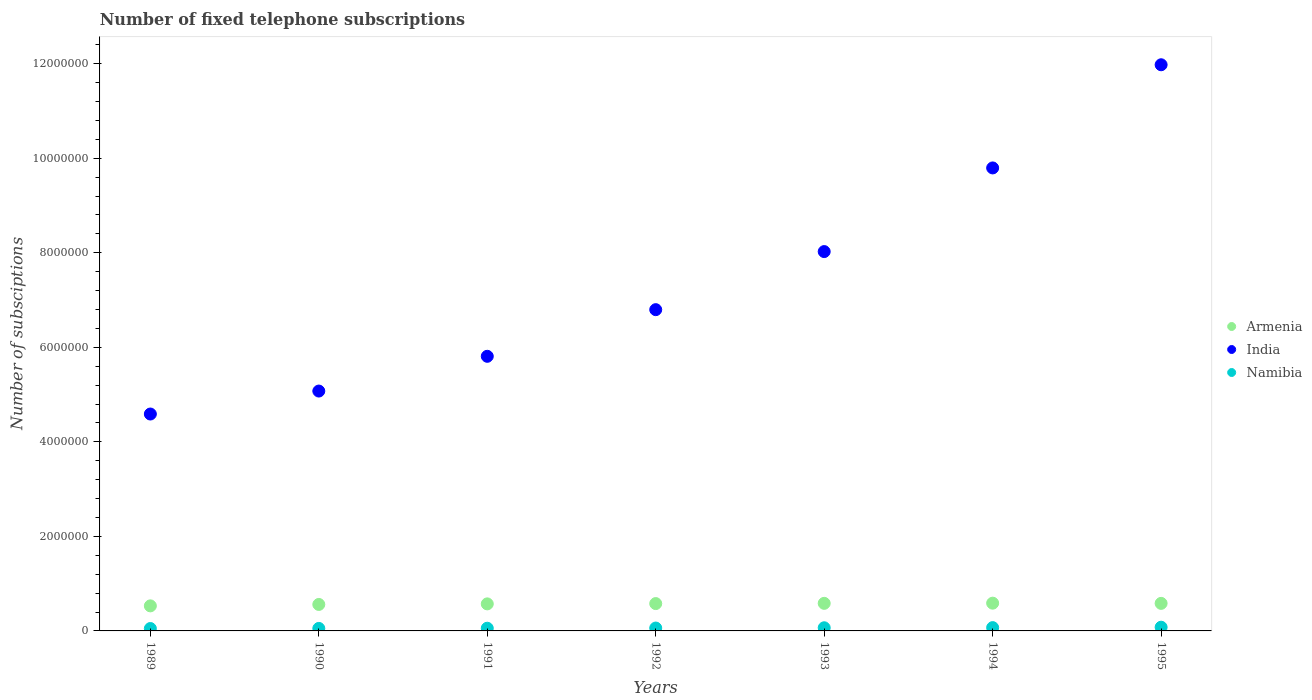How many different coloured dotlines are there?
Your answer should be very brief. 3. What is the number of fixed telephone subscriptions in Armenia in 1989?
Provide a succinct answer. 5.30e+05. Across all years, what is the maximum number of fixed telephone subscriptions in Namibia?
Offer a terse response. 7.85e+04. Across all years, what is the minimum number of fixed telephone subscriptions in Namibia?
Your answer should be very brief. 5.07e+04. In which year was the number of fixed telephone subscriptions in Armenia maximum?
Ensure brevity in your answer.  1994. In which year was the number of fixed telephone subscriptions in Armenia minimum?
Your answer should be compact. 1989. What is the total number of fixed telephone subscriptions in India in the graph?
Provide a succinct answer. 5.21e+07. What is the difference between the number of fixed telephone subscriptions in India in 1991 and that in 1995?
Your answer should be compact. -6.17e+06. What is the difference between the number of fixed telephone subscriptions in Namibia in 1993 and the number of fixed telephone subscriptions in India in 1992?
Make the answer very short. -6.73e+06. What is the average number of fixed telephone subscriptions in Namibia per year?
Your answer should be compact. 6.24e+04. In the year 1990, what is the difference between the number of fixed telephone subscriptions in Armenia and number of fixed telephone subscriptions in Namibia?
Provide a succinct answer. 5.07e+05. In how many years, is the number of fixed telephone subscriptions in India greater than 10400000?
Keep it short and to the point. 1. What is the ratio of the number of fixed telephone subscriptions in Namibia in 1989 to that in 1995?
Make the answer very short. 0.65. Is the number of fixed telephone subscriptions in Armenia in 1990 less than that in 1991?
Keep it short and to the point. Yes. Is the difference between the number of fixed telephone subscriptions in Armenia in 1992 and 1994 greater than the difference between the number of fixed telephone subscriptions in Namibia in 1992 and 1994?
Give a very brief answer. Yes. What is the difference between the highest and the second highest number of fixed telephone subscriptions in India?
Your response must be concise. 2.18e+06. What is the difference between the highest and the lowest number of fixed telephone subscriptions in Namibia?
Your answer should be very brief. 2.78e+04. In how many years, is the number of fixed telephone subscriptions in India greater than the average number of fixed telephone subscriptions in India taken over all years?
Provide a succinct answer. 3. Is the sum of the number of fixed telephone subscriptions in India in 1989 and 1994 greater than the maximum number of fixed telephone subscriptions in Namibia across all years?
Make the answer very short. Yes. Is it the case that in every year, the sum of the number of fixed telephone subscriptions in Armenia and number of fixed telephone subscriptions in Namibia  is greater than the number of fixed telephone subscriptions in India?
Offer a very short reply. No. Does the number of fixed telephone subscriptions in Armenia monotonically increase over the years?
Your response must be concise. No. Is the number of fixed telephone subscriptions in India strictly greater than the number of fixed telephone subscriptions in Namibia over the years?
Give a very brief answer. Yes. Is the number of fixed telephone subscriptions in Armenia strictly less than the number of fixed telephone subscriptions in Namibia over the years?
Provide a succinct answer. No. How many dotlines are there?
Keep it short and to the point. 3. What is the difference between two consecutive major ticks on the Y-axis?
Make the answer very short. 2.00e+06. Are the values on the major ticks of Y-axis written in scientific E-notation?
Provide a succinct answer. No. How many legend labels are there?
Your response must be concise. 3. How are the legend labels stacked?
Give a very brief answer. Vertical. What is the title of the graph?
Offer a very short reply. Number of fixed telephone subscriptions. What is the label or title of the Y-axis?
Offer a very short reply. Number of subsciptions. What is the Number of subsciptions of Armenia in 1989?
Your answer should be compact. 5.30e+05. What is the Number of subsciptions in India in 1989?
Offer a terse response. 4.59e+06. What is the Number of subsciptions in Namibia in 1989?
Provide a short and direct response. 5.07e+04. What is the Number of subsciptions of Armenia in 1990?
Offer a very short reply. 5.60e+05. What is the Number of subsciptions of India in 1990?
Provide a short and direct response. 5.07e+06. What is the Number of subsciptions of Namibia in 1990?
Offer a terse response. 5.30e+04. What is the Number of subsciptions in Armenia in 1991?
Offer a very short reply. 5.72e+05. What is the Number of subsciptions in India in 1991?
Provide a short and direct response. 5.81e+06. What is the Number of subsciptions of Namibia in 1991?
Keep it short and to the point. 5.69e+04. What is the Number of subsciptions in Armenia in 1992?
Keep it short and to the point. 5.78e+05. What is the Number of subsciptions in India in 1992?
Keep it short and to the point. 6.80e+06. What is the Number of subsciptions of Namibia in 1992?
Offer a very short reply. 6.10e+04. What is the Number of subsciptions of Armenia in 1993?
Your answer should be very brief. 5.83e+05. What is the Number of subsciptions in India in 1993?
Make the answer very short. 8.03e+06. What is the Number of subsciptions of Namibia in 1993?
Your response must be concise. 6.67e+04. What is the Number of subsciptions of Armenia in 1994?
Provide a succinct answer. 5.87e+05. What is the Number of subsciptions of India in 1994?
Your answer should be compact. 9.80e+06. What is the Number of subsciptions in Namibia in 1994?
Keep it short and to the point. 6.98e+04. What is the Number of subsciptions of Armenia in 1995?
Keep it short and to the point. 5.83e+05. What is the Number of subsciptions in India in 1995?
Give a very brief answer. 1.20e+07. What is the Number of subsciptions in Namibia in 1995?
Offer a terse response. 7.85e+04. Across all years, what is the maximum Number of subsciptions of Armenia?
Provide a short and direct response. 5.87e+05. Across all years, what is the maximum Number of subsciptions of India?
Ensure brevity in your answer.  1.20e+07. Across all years, what is the maximum Number of subsciptions of Namibia?
Ensure brevity in your answer.  7.85e+04. Across all years, what is the minimum Number of subsciptions in Armenia?
Provide a short and direct response. 5.30e+05. Across all years, what is the minimum Number of subsciptions of India?
Provide a succinct answer. 4.59e+06. Across all years, what is the minimum Number of subsciptions in Namibia?
Ensure brevity in your answer.  5.07e+04. What is the total Number of subsciptions in Armenia in the graph?
Offer a very short reply. 3.99e+06. What is the total Number of subsciptions of India in the graph?
Your answer should be very brief. 5.21e+07. What is the total Number of subsciptions of Namibia in the graph?
Provide a succinct answer. 4.37e+05. What is the difference between the Number of subsciptions of Armenia in 1989 and that in 1990?
Your response must be concise. -3.00e+04. What is the difference between the Number of subsciptions in India in 1989 and that in 1990?
Provide a succinct answer. -4.86e+05. What is the difference between the Number of subsciptions in Namibia in 1989 and that in 1990?
Your answer should be compact. -2332. What is the difference between the Number of subsciptions of Armenia in 1989 and that in 1991?
Give a very brief answer. -4.21e+04. What is the difference between the Number of subsciptions in India in 1989 and that in 1991?
Your answer should be very brief. -1.22e+06. What is the difference between the Number of subsciptions of Namibia in 1989 and that in 1991?
Your answer should be compact. -6271. What is the difference between the Number of subsciptions of Armenia in 1989 and that in 1992?
Provide a succinct answer. -4.84e+04. What is the difference between the Number of subsciptions in India in 1989 and that in 1992?
Your answer should be very brief. -2.21e+06. What is the difference between the Number of subsciptions of Namibia in 1989 and that in 1992?
Give a very brief answer. -1.03e+04. What is the difference between the Number of subsciptions in Armenia in 1989 and that in 1993?
Offer a terse response. -5.35e+04. What is the difference between the Number of subsciptions of India in 1989 and that in 1993?
Provide a succinct answer. -3.44e+06. What is the difference between the Number of subsciptions in Namibia in 1989 and that in 1993?
Your answer should be very brief. -1.61e+04. What is the difference between the Number of subsciptions in Armenia in 1989 and that in 1994?
Your answer should be compact. -5.71e+04. What is the difference between the Number of subsciptions in India in 1989 and that in 1994?
Your answer should be very brief. -5.21e+06. What is the difference between the Number of subsciptions in Namibia in 1989 and that in 1994?
Provide a short and direct response. -1.91e+04. What is the difference between the Number of subsciptions in Armenia in 1989 and that in 1995?
Offer a very short reply. -5.28e+04. What is the difference between the Number of subsciptions of India in 1989 and that in 1995?
Your answer should be very brief. -7.39e+06. What is the difference between the Number of subsciptions in Namibia in 1989 and that in 1995?
Provide a succinct answer. -2.78e+04. What is the difference between the Number of subsciptions in Armenia in 1990 and that in 1991?
Provide a short and direct response. -1.21e+04. What is the difference between the Number of subsciptions in India in 1990 and that in 1991?
Provide a succinct answer. -7.35e+05. What is the difference between the Number of subsciptions of Namibia in 1990 and that in 1991?
Offer a terse response. -3939. What is the difference between the Number of subsciptions in Armenia in 1990 and that in 1992?
Your response must be concise. -1.84e+04. What is the difference between the Number of subsciptions in India in 1990 and that in 1992?
Offer a terse response. -1.72e+06. What is the difference between the Number of subsciptions of Namibia in 1990 and that in 1992?
Provide a short and direct response. -7974. What is the difference between the Number of subsciptions of Armenia in 1990 and that in 1993?
Make the answer very short. -2.35e+04. What is the difference between the Number of subsciptions of India in 1990 and that in 1993?
Provide a short and direct response. -2.95e+06. What is the difference between the Number of subsciptions of Namibia in 1990 and that in 1993?
Offer a very short reply. -1.37e+04. What is the difference between the Number of subsciptions of Armenia in 1990 and that in 1994?
Ensure brevity in your answer.  -2.71e+04. What is the difference between the Number of subsciptions in India in 1990 and that in 1994?
Provide a short and direct response. -4.72e+06. What is the difference between the Number of subsciptions in Namibia in 1990 and that in 1994?
Ensure brevity in your answer.  -1.68e+04. What is the difference between the Number of subsciptions of Armenia in 1990 and that in 1995?
Your answer should be very brief. -2.28e+04. What is the difference between the Number of subsciptions in India in 1990 and that in 1995?
Ensure brevity in your answer.  -6.90e+06. What is the difference between the Number of subsciptions of Namibia in 1990 and that in 1995?
Your answer should be very brief. -2.55e+04. What is the difference between the Number of subsciptions of Armenia in 1991 and that in 1992?
Make the answer very short. -6300. What is the difference between the Number of subsciptions in India in 1991 and that in 1992?
Keep it short and to the point. -9.87e+05. What is the difference between the Number of subsciptions in Namibia in 1991 and that in 1992?
Offer a very short reply. -4035. What is the difference between the Number of subsciptions of Armenia in 1991 and that in 1993?
Make the answer very short. -1.14e+04. What is the difference between the Number of subsciptions of India in 1991 and that in 1993?
Your answer should be compact. -2.22e+06. What is the difference between the Number of subsciptions in Namibia in 1991 and that in 1993?
Provide a succinct answer. -9810. What is the difference between the Number of subsciptions in Armenia in 1991 and that in 1994?
Offer a terse response. -1.50e+04. What is the difference between the Number of subsciptions in India in 1991 and that in 1994?
Provide a succinct answer. -3.99e+06. What is the difference between the Number of subsciptions of Namibia in 1991 and that in 1994?
Keep it short and to the point. -1.28e+04. What is the difference between the Number of subsciptions of Armenia in 1991 and that in 1995?
Your answer should be very brief. -1.07e+04. What is the difference between the Number of subsciptions of India in 1991 and that in 1995?
Offer a terse response. -6.17e+06. What is the difference between the Number of subsciptions in Namibia in 1991 and that in 1995?
Your answer should be very brief. -2.16e+04. What is the difference between the Number of subsciptions of Armenia in 1992 and that in 1993?
Your answer should be very brief. -5060. What is the difference between the Number of subsciptions of India in 1992 and that in 1993?
Provide a short and direct response. -1.23e+06. What is the difference between the Number of subsciptions of Namibia in 1992 and that in 1993?
Offer a very short reply. -5775. What is the difference between the Number of subsciptions in Armenia in 1992 and that in 1994?
Ensure brevity in your answer.  -8713. What is the difference between the Number of subsciptions in India in 1992 and that in 1994?
Your answer should be very brief. -3.00e+06. What is the difference between the Number of subsciptions in Namibia in 1992 and that in 1994?
Offer a very short reply. -8810. What is the difference between the Number of subsciptions of Armenia in 1992 and that in 1995?
Make the answer very short. -4400. What is the difference between the Number of subsciptions of India in 1992 and that in 1995?
Provide a succinct answer. -5.18e+06. What is the difference between the Number of subsciptions in Namibia in 1992 and that in 1995?
Your answer should be very brief. -1.75e+04. What is the difference between the Number of subsciptions of Armenia in 1993 and that in 1994?
Your answer should be compact. -3653. What is the difference between the Number of subsciptions in India in 1993 and that in 1994?
Ensure brevity in your answer.  -1.77e+06. What is the difference between the Number of subsciptions of Namibia in 1993 and that in 1994?
Keep it short and to the point. -3035. What is the difference between the Number of subsciptions of Armenia in 1993 and that in 1995?
Your answer should be compact. 660. What is the difference between the Number of subsciptions in India in 1993 and that in 1995?
Offer a terse response. -3.95e+06. What is the difference between the Number of subsciptions in Namibia in 1993 and that in 1995?
Give a very brief answer. -1.18e+04. What is the difference between the Number of subsciptions in Armenia in 1994 and that in 1995?
Ensure brevity in your answer.  4313. What is the difference between the Number of subsciptions in India in 1994 and that in 1995?
Provide a succinct answer. -2.18e+06. What is the difference between the Number of subsciptions of Namibia in 1994 and that in 1995?
Give a very brief answer. -8715. What is the difference between the Number of subsciptions in Armenia in 1989 and the Number of subsciptions in India in 1990?
Offer a terse response. -4.54e+06. What is the difference between the Number of subsciptions of Armenia in 1989 and the Number of subsciptions of Namibia in 1990?
Offer a terse response. 4.77e+05. What is the difference between the Number of subsciptions of India in 1989 and the Number of subsciptions of Namibia in 1990?
Keep it short and to the point. 4.54e+06. What is the difference between the Number of subsciptions in Armenia in 1989 and the Number of subsciptions in India in 1991?
Keep it short and to the point. -5.28e+06. What is the difference between the Number of subsciptions in Armenia in 1989 and the Number of subsciptions in Namibia in 1991?
Your answer should be compact. 4.73e+05. What is the difference between the Number of subsciptions in India in 1989 and the Number of subsciptions in Namibia in 1991?
Provide a short and direct response. 4.53e+06. What is the difference between the Number of subsciptions of Armenia in 1989 and the Number of subsciptions of India in 1992?
Provide a short and direct response. -6.27e+06. What is the difference between the Number of subsciptions of Armenia in 1989 and the Number of subsciptions of Namibia in 1992?
Offer a very short reply. 4.69e+05. What is the difference between the Number of subsciptions of India in 1989 and the Number of subsciptions of Namibia in 1992?
Make the answer very short. 4.53e+06. What is the difference between the Number of subsciptions of Armenia in 1989 and the Number of subsciptions of India in 1993?
Make the answer very short. -7.50e+06. What is the difference between the Number of subsciptions in Armenia in 1989 and the Number of subsciptions in Namibia in 1993?
Keep it short and to the point. 4.63e+05. What is the difference between the Number of subsciptions in India in 1989 and the Number of subsciptions in Namibia in 1993?
Provide a succinct answer. 4.52e+06. What is the difference between the Number of subsciptions of Armenia in 1989 and the Number of subsciptions of India in 1994?
Your response must be concise. -9.27e+06. What is the difference between the Number of subsciptions in Armenia in 1989 and the Number of subsciptions in Namibia in 1994?
Offer a terse response. 4.60e+05. What is the difference between the Number of subsciptions in India in 1989 and the Number of subsciptions in Namibia in 1994?
Provide a short and direct response. 4.52e+06. What is the difference between the Number of subsciptions of Armenia in 1989 and the Number of subsciptions of India in 1995?
Provide a short and direct response. -1.14e+07. What is the difference between the Number of subsciptions of Armenia in 1989 and the Number of subsciptions of Namibia in 1995?
Make the answer very short. 4.52e+05. What is the difference between the Number of subsciptions of India in 1989 and the Number of subsciptions of Namibia in 1995?
Provide a short and direct response. 4.51e+06. What is the difference between the Number of subsciptions of Armenia in 1990 and the Number of subsciptions of India in 1991?
Make the answer very short. -5.25e+06. What is the difference between the Number of subsciptions of Armenia in 1990 and the Number of subsciptions of Namibia in 1991?
Offer a terse response. 5.03e+05. What is the difference between the Number of subsciptions of India in 1990 and the Number of subsciptions of Namibia in 1991?
Offer a very short reply. 5.02e+06. What is the difference between the Number of subsciptions of Armenia in 1990 and the Number of subsciptions of India in 1992?
Make the answer very short. -6.24e+06. What is the difference between the Number of subsciptions of Armenia in 1990 and the Number of subsciptions of Namibia in 1992?
Offer a very short reply. 4.99e+05. What is the difference between the Number of subsciptions of India in 1990 and the Number of subsciptions of Namibia in 1992?
Your answer should be very brief. 5.01e+06. What is the difference between the Number of subsciptions of Armenia in 1990 and the Number of subsciptions of India in 1993?
Provide a succinct answer. -7.47e+06. What is the difference between the Number of subsciptions in Armenia in 1990 and the Number of subsciptions in Namibia in 1993?
Make the answer very short. 4.93e+05. What is the difference between the Number of subsciptions in India in 1990 and the Number of subsciptions in Namibia in 1993?
Keep it short and to the point. 5.01e+06. What is the difference between the Number of subsciptions in Armenia in 1990 and the Number of subsciptions in India in 1994?
Your response must be concise. -9.24e+06. What is the difference between the Number of subsciptions of Armenia in 1990 and the Number of subsciptions of Namibia in 1994?
Offer a terse response. 4.90e+05. What is the difference between the Number of subsciptions of India in 1990 and the Number of subsciptions of Namibia in 1994?
Your answer should be compact. 5.00e+06. What is the difference between the Number of subsciptions in Armenia in 1990 and the Number of subsciptions in India in 1995?
Provide a short and direct response. -1.14e+07. What is the difference between the Number of subsciptions in Armenia in 1990 and the Number of subsciptions in Namibia in 1995?
Ensure brevity in your answer.  4.82e+05. What is the difference between the Number of subsciptions of India in 1990 and the Number of subsciptions of Namibia in 1995?
Your answer should be very brief. 5.00e+06. What is the difference between the Number of subsciptions of Armenia in 1991 and the Number of subsciptions of India in 1992?
Keep it short and to the point. -6.22e+06. What is the difference between the Number of subsciptions of Armenia in 1991 and the Number of subsciptions of Namibia in 1992?
Ensure brevity in your answer.  5.11e+05. What is the difference between the Number of subsciptions in India in 1991 and the Number of subsciptions in Namibia in 1992?
Keep it short and to the point. 5.75e+06. What is the difference between the Number of subsciptions of Armenia in 1991 and the Number of subsciptions of India in 1993?
Offer a terse response. -7.45e+06. What is the difference between the Number of subsciptions of Armenia in 1991 and the Number of subsciptions of Namibia in 1993?
Ensure brevity in your answer.  5.05e+05. What is the difference between the Number of subsciptions of India in 1991 and the Number of subsciptions of Namibia in 1993?
Ensure brevity in your answer.  5.74e+06. What is the difference between the Number of subsciptions in Armenia in 1991 and the Number of subsciptions in India in 1994?
Provide a succinct answer. -9.22e+06. What is the difference between the Number of subsciptions of Armenia in 1991 and the Number of subsciptions of Namibia in 1994?
Offer a terse response. 5.02e+05. What is the difference between the Number of subsciptions of India in 1991 and the Number of subsciptions of Namibia in 1994?
Provide a succinct answer. 5.74e+06. What is the difference between the Number of subsciptions in Armenia in 1991 and the Number of subsciptions in India in 1995?
Ensure brevity in your answer.  -1.14e+07. What is the difference between the Number of subsciptions in Armenia in 1991 and the Number of subsciptions in Namibia in 1995?
Ensure brevity in your answer.  4.94e+05. What is the difference between the Number of subsciptions in India in 1991 and the Number of subsciptions in Namibia in 1995?
Make the answer very short. 5.73e+06. What is the difference between the Number of subsciptions of Armenia in 1992 and the Number of subsciptions of India in 1993?
Provide a short and direct response. -7.45e+06. What is the difference between the Number of subsciptions in Armenia in 1992 and the Number of subsciptions in Namibia in 1993?
Provide a short and direct response. 5.12e+05. What is the difference between the Number of subsciptions in India in 1992 and the Number of subsciptions in Namibia in 1993?
Your answer should be very brief. 6.73e+06. What is the difference between the Number of subsciptions of Armenia in 1992 and the Number of subsciptions of India in 1994?
Ensure brevity in your answer.  -9.22e+06. What is the difference between the Number of subsciptions of Armenia in 1992 and the Number of subsciptions of Namibia in 1994?
Offer a terse response. 5.09e+05. What is the difference between the Number of subsciptions in India in 1992 and the Number of subsciptions in Namibia in 1994?
Make the answer very short. 6.73e+06. What is the difference between the Number of subsciptions in Armenia in 1992 and the Number of subsciptions in India in 1995?
Offer a very short reply. -1.14e+07. What is the difference between the Number of subsciptions of Armenia in 1992 and the Number of subsciptions of Namibia in 1995?
Your answer should be compact. 5.00e+05. What is the difference between the Number of subsciptions in India in 1992 and the Number of subsciptions in Namibia in 1995?
Provide a short and direct response. 6.72e+06. What is the difference between the Number of subsciptions of Armenia in 1993 and the Number of subsciptions of India in 1994?
Make the answer very short. -9.21e+06. What is the difference between the Number of subsciptions in Armenia in 1993 and the Number of subsciptions in Namibia in 1994?
Provide a short and direct response. 5.14e+05. What is the difference between the Number of subsciptions of India in 1993 and the Number of subsciptions of Namibia in 1994?
Offer a very short reply. 7.96e+06. What is the difference between the Number of subsciptions in Armenia in 1993 and the Number of subsciptions in India in 1995?
Ensure brevity in your answer.  -1.14e+07. What is the difference between the Number of subsciptions of Armenia in 1993 and the Number of subsciptions of Namibia in 1995?
Offer a terse response. 5.05e+05. What is the difference between the Number of subsciptions in India in 1993 and the Number of subsciptions in Namibia in 1995?
Keep it short and to the point. 7.95e+06. What is the difference between the Number of subsciptions of Armenia in 1994 and the Number of subsciptions of India in 1995?
Give a very brief answer. -1.14e+07. What is the difference between the Number of subsciptions in Armenia in 1994 and the Number of subsciptions in Namibia in 1995?
Offer a terse response. 5.09e+05. What is the difference between the Number of subsciptions of India in 1994 and the Number of subsciptions of Namibia in 1995?
Provide a succinct answer. 9.72e+06. What is the average Number of subsciptions in Armenia per year?
Provide a short and direct response. 5.71e+05. What is the average Number of subsciptions in India per year?
Keep it short and to the point. 7.44e+06. What is the average Number of subsciptions in Namibia per year?
Offer a very short reply. 6.24e+04. In the year 1989, what is the difference between the Number of subsciptions in Armenia and Number of subsciptions in India?
Provide a succinct answer. -4.06e+06. In the year 1989, what is the difference between the Number of subsciptions in Armenia and Number of subsciptions in Namibia?
Provide a succinct answer. 4.79e+05. In the year 1989, what is the difference between the Number of subsciptions of India and Number of subsciptions of Namibia?
Your answer should be very brief. 4.54e+06. In the year 1990, what is the difference between the Number of subsciptions of Armenia and Number of subsciptions of India?
Make the answer very short. -4.51e+06. In the year 1990, what is the difference between the Number of subsciptions of Armenia and Number of subsciptions of Namibia?
Make the answer very short. 5.07e+05. In the year 1990, what is the difference between the Number of subsciptions of India and Number of subsciptions of Namibia?
Keep it short and to the point. 5.02e+06. In the year 1991, what is the difference between the Number of subsciptions in Armenia and Number of subsciptions in India?
Your answer should be very brief. -5.24e+06. In the year 1991, what is the difference between the Number of subsciptions in Armenia and Number of subsciptions in Namibia?
Ensure brevity in your answer.  5.15e+05. In the year 1991, what is the difference between the Number of subsciptions in India and Number of subsciptions in Namibia?
Your response must be concise. 5.75e+06. In the year 1992, what is the difference between the Number of subsciptions of Armenia and Number of subsciptions of India?
Offer a very short reply. -6.22e+06. In the year 1992, what is the difference between the Number of subsciptions in Armenia and Number of subsciptions in Namibia?
Give a very brief answer. 5.17e+05. In the year 1992, what is the difference between the Number of subsciptions in India and Number of subsciptions in Namibia?
Keep it short and to the point. 6.74e+06. In the year 1993, what is the difference between the Number of subsciptions of Armenia and Number of subsciptions of India?
Your answer should be compact. -7.44e+06. In the year 1993, what is the difference between the Number of subsciptions in Armenia and Number of subsciptions in Namibia?
Offer a very short reply. 5.17e+05. In the year 1993, what is the difference between the Number of subsciptions in India and Number of subsciptions in Namibia?
Your answer should be very brief. 7.96e+06. In the year 1994, what is the difference between the Number of subsciptions of Armenia and Number of subsciptions of India?
Your answer should be compact. -9.21e+06. In the year 1994, what is the difference between the Number of subsciptions in Armenia and Number of subsciptions in Namibia?
Provide a succinct answer. 5.17e+05. In the year 1994, what is the difference between the Number of subsciptions of India and Number of subsciptions of Namibia?
Offer a very short reply. 9.73e+06. In the year 1995, what is the difference between the Number of subsciptions of Armenia and Number of subsciptions of India?
Provide a succinct answer. -1.14e+07. In the year 1995, what is the difference between the Number of subsciptions in Armenia and Number of subsciptions in Namibia?
Your answer should be compact. 5.04e+05. In the year 1995, what is the difference between the Number of subsciptions of India and Number of subsciptions of Namibia?
Provide a succinct answer. 1.19e+07. What is the ratio of the Number of subsciptions in Armenia in 1989 to that in 1990?
Offer a very short reply. 0.95. What is the ratio of the Number of subsciptions of India in 1989 to that in 1990?
Your response must be concise. 0.9. What is the ratio of the Number of subsciptions of Namibia in 1989 to that in 1990?
Your response must be concise. 0.96. What is the ratio of the Number of subsciptions of Armenia in 1989 to that in 1991?
Make the answer very short. 0.93. What is the ratio of the Number of subsciptions of India in 1989 to that in 1991?
Ensure brevity in your answer.  0.79. What is the ratio of the Number of subsciptions of Namibia in 1989 to that in 1991?
Your response must be concise. 0.89. What is the ratio of the Number of subsciptions in Armenia in 1989 to that in 1992?
Keep it short and to the point. 0.92. What is the ratio of the Number of subsciptions in India in 1989 to that in 1992?
Offer a very short reply. 0.68. What is the ratio of the Number of subsciptions in Namibia in 1989 to that in 1992?
Make the answer very short. 0.83. What is the ratio of the Number of subsciptions in Armenia in 1989 to that in 1993?
Make the answer very short. 0.91. What is the ratio of the Number of subsciptions of India in 1989 to that in 1993?
Your answer should be very brief. 0.57. What is the ratio of the Number of subsciptions in Namibia in 1989 to that in 1993?
Make the answer very short. 0.76. What is the ratio of the Number of subsciptions of Armenia in 1989 to that in 1994?
Ensure brevity in your answer.  0.9. What is the ratio of the Number of subsciptions in India in 1989 to that in 1994?
Offer a terse response. 0.47. What is the ratio of the Number of subsciptions in Namibia in 1989 to that in 1994?
Give a very brief answer. 0.73. What is the ratio of the Number of subsciptions of Armenia in 1989 to that in 1995?
Keep it short and to the point. 0.91. What is the ratio of the Number of subsciptions in India in 1989 to that in 1995?
Your response must be concise. 0.38. What is the ratio of the Number of subsciptions of Namibia in 1989 to that in 1995?
Offer a terse response. 0.65. What is the ratio of the Number of subsciptions in Armenia in 1990 to that in 1991?
Offer a very short reply. 0.98. What is the ratio of the Number of subsciptions of India in 1990 to that in 1991?
Give a very brief answer. 0.87. What is the ratio of the Number of subsciptions of Namibia in 1990 to that in 1991?
Your answer should be very brief. 0.93. What is the ratio of the Number of subsciptions of Armenia in 1990 to that in 1992?
Provide a succinct answer. 0.97. What is the ratio of the Number of subsciptions of India in 1990 to that in 1992?
Your response must be concise. 0.75. What is the ratio of the Number of subsciptions in Namibia in 1990 to that in 1992?
Provide a succinct answer. 0.87. What is the ratio of the Number of subsciptions in Armenia in 1990 to that in 1993?
Make the answer very short. 0.96. What is the ratio of the Number of subsciptions of India in 1990 to that in 1993?
Provide a short and direct response. 0.63. What is the ratio of the Number of subsciptions in Namibia in 1990 to that in 1993?
Your answer should be compact. 0.79. What is the ratio of the Number of subsciptions in Armenia in 1990 to that in 1994?
Your answer should be very brief. 0.95. What is the ratio of the Number of subsciptions of India in 1990 to that in 1994?
Keep it short and to the point. 0.52. What is the ratio of the Number of subsciptions in Namibia in 1990 to that in 1994?
Your answer should be compact. 0.76. What is the ratio of the Number of subsciptions of Armenia in 1990 to that in 1995?
Provide a short and direct response. 0.96. What is the ratio of the Number of subsciptions in India in 1990 to that in 1995?
Provide a succinct answer. 0.42. What is the ratio of the Number of subsciptions of Namibia in 1990 to that in 1995?
Ensure brevity in your answer.  0.68. What is the ratio of the Number of subsciptions in Armenia in 1991 to that in 1992?
Your response must be concise. 0.99. What is the ratio of the Number of subsciptions in India in 1991 to that in 1992?
Keep it short and to the point. 0.85. What is the ratio of the Number of subsciptions in Namibia in 1991 to that in 1992?
Provide a short and direct response. 0.93. What is the ratio of the Number of subsciptions of Armenia in 1991 to that in 1993?
Offer a terse response. 0.98. What is the ratio of the Number of subsciptions in India in 1991 to that in 1993?
Ensure brevity in your answer.  0.72. What is the ratio of the Number of subsciptions of Namibia in 1991 to that in 1993?
Offer a terse response. 0.85. What is the ratio of the Number of subsciptions in Armenia in 1991 to that in 1994?
Provide a succinct answer. 0.97. What is the ratio of the Number of subsciptions in India in 1991 to that in 1994?
Ensure brevity in your answer.  0.59. What is the ratio of the Number of subsciptions of Namibia in 1991 to that in 1994?
Offer a terse response. 0.82. What is the ratio of the Number of subsciptions of Armenia in 1991 to that in 1995?
Your response must be concise. 0.98. What is the ratio of the Number of subsciptions in India in 1991 to that in 1995?
Provide a succinct answer. 0.49. What is the ratio of the Number of subsciptions in Namibia in 1991 to that in 1995?
Ensure brevity in your answer.  0.73. What is the ratio of the Number of subsciptions in India in 1992 to that in 1993?
Offer a terse response. 0.85. What is the ratio of the Number of subsciptions in Namibia in 1992 to that in 1993?
Offer a very short reply. 0.91. What is the ratio of the Number of subsciptions of Armenia in 1992 to that in 1994?
Offer a very short reply. 0.99. What is the ratio of the Number of subsciptions of India in 1992 to that in 1994?
Keep it short and to the point. 0.69. What is the ratio of the Number of subsciptions in Namibia in 1992 to that in 1994?
Your response must be concise. 0.87. What is the ratio of the Number of subsciptions of Armenia in 1992 to that in 1995?
Give a very brief answer. 0.99. What is the ratio of the Number of subsciptions in India in 1992 to that in 1995?
Offer a very short reply. 0.57. What is the ratio of the Number of subsciptions in Namibia in 1992 to that in 1995?
Provide a succinct answer. 0.78. What is the ratio of the Number of subsciptions of Armenia in 1993 to that in 1994?
Your response must be concise. 0.99. What is the ratio of the Number of subsciptions in India in 1993 to that in 1994?
Provide a succinct answer. 0.82. What is the ratio of the Number of subsciptions of Namibia in 1993 to that in 1994?
Keep it short and to the point. 0.96. What is the ratio of the Number of subsciptions in India in 1993 to that in 1995?
Keep it short and to the point. 0.67. What is the ratio of the Number of subsciptions in Namibia in 1993 to that in 1995?
Your answer should be compact. 0.85. What is the ratio of the Number of subsciptions of Armenia in 1994 to that in 1995?
Provide a succinct answer. 1.01. What is the ratio of the Number of subsciptions of India in 1994 to that in 1995?
Ensure brevity in your answer.  0.82. What is the ratio of the Number of subsciptions in Namibia in 1994 to that in 1995?
Keep it short and to the point. 0.89. What is the difference between the highest and the second highest Number of subsciptions of Armenia?
Make the answer very short. 3653. What is the difference between the highest and the second highest Number of subsciptions of India?
Provide a short and direct response. 2.18e+06. What is the difference between the highest and the second highest Number of subsciptions in Namibia?
Offer a very short reply. 8715. What is the difference between the highest and the lowest Number of subsciptions of Armenia?
Ensure brevity in your answer.  5.71e+04. What is the difference between the highest and the lowest Number of subsciptions in India?
Offer a very short reply. 7.39e+06. What is the difference between the highest and the lowest Number of subsciptions of Namibia?
Offer a terse response. 2.78e+04. 